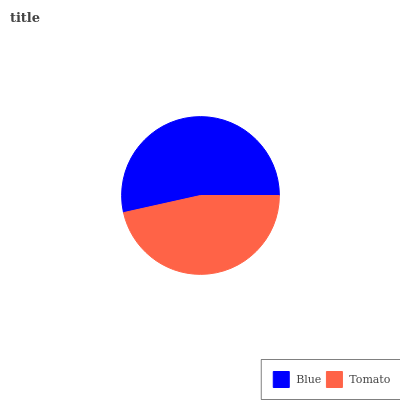Is Tomato the minimum?
Answer yes or no. Yes. Is Blue the maximum?
Answer yes or no. Yes. Is Tomato the maximum?
Answer yes or no. No. Is Blue greater than Tomato?
Answer yes or no. Yes. Is Tomato less than Blue?
Answer yes or no. Yes. Is Tomato greater than Blue?
Answer yes or no. No. Is Blue less than Tomato?
Answer yes or no. No. Is Blue the high median?
Answer yes or no. Yes. Is Tomato the low median?
Answer yes or no. Yes. Is Tomato the high median?
Answer yes or no. No. Is Blue the low median?
Answer yes or no. No. 